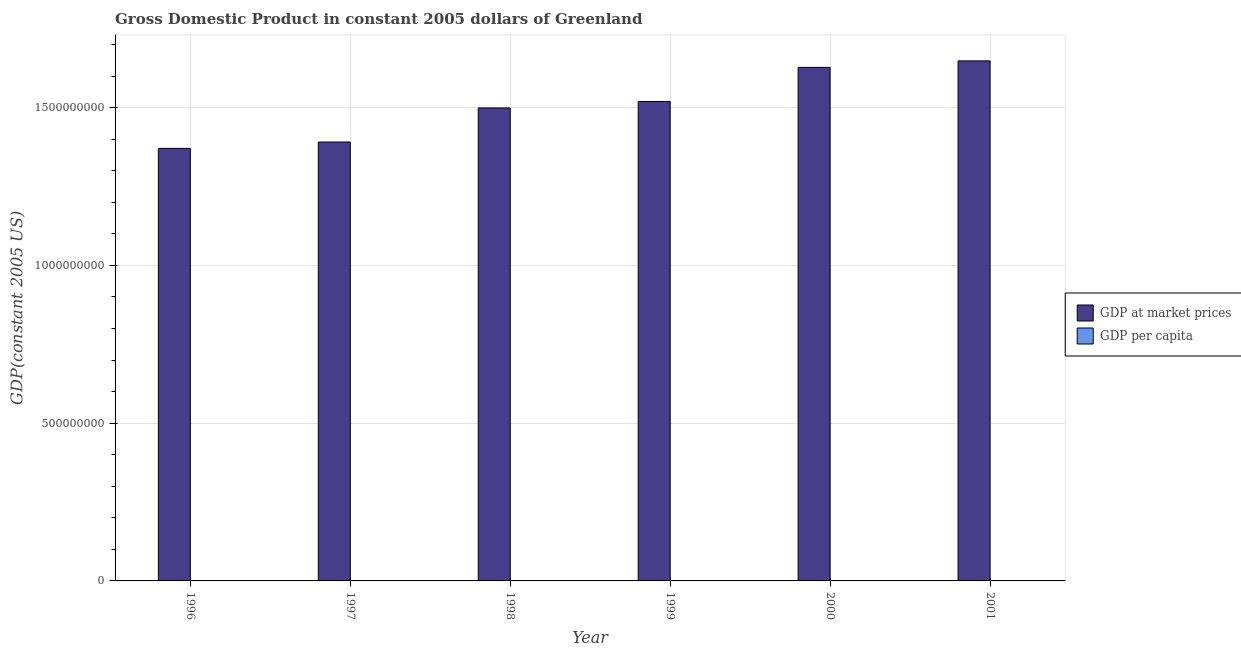How many different coloured bars are there?
Offer a terse response. 2. How many groups of bars are there?
Your answer should be compact. 6. Are the number of bars on each tick of the X-axis equal?
Keep it short and to the point. Yes. How many bars are there on the 1st tick from the left?
Your answer should be compact. 2. What is the label of the 6th group of bars from the left?
Give a very brief answer. 2001. What is the gdp per capita in 2000?
Your response must be concise. 2.90e+04. Across all years, what is the maximum gdp at market prices?
Offer a terse response. 1.65e+09. Across all years, what is the minimum gdp at market prices?
Keep it short and to the point. 1.37e+09. In which year was the gdp per capita minimum?
Provide a succinct answer. 1996. What is the total gdp at market prices in the graph?
Offer a terse response. 9.06e+09. What is the difference between the gdp at market prices in 1996 and that in 1998?
Make the answer very short. -1.28e+08. What is the difference between the gdp per capita in 1996 and the gdp at market prices in 1999?
Ensure brevity in your answer.  -2563.56. What is the average gdp per capita per year?
Provide a short and direct response. 2.69e+04. In how many years, is the gdp per capita greater than 1000000000 US$?
Make the answer very short. 0. What is the ratio of the gdp per capita in 1998 to that in 2000?
Your answer should be compact. 0.92. Is the gdp per capita in 1998 less than that in 2001?
Provide a succinct answer. Yes. Is the difference between the gdp per capita in 1998 and 2001 greater than the difference between the gdp at market prices in 1998 and 2001?
Your response must be concise. No. What is the difference between the highest and the second highest gdp per capita?
Make the answer very short. 289.47. What is the difference between the highest and the lowest gdp at market prices?
Your answer should be very brief. 2.77e+08. In how many years, is the gdp at market prices greater than the average gdp at market prices taken over all years?
Your response must be concise. 3. Is the sum of the gdp per capita in 1999 and 2001 greater than the maximum gdp at market prices across all years?
Offer a very short reply. Yes. What does the 1st bar from the left in 2000 represents?
Provide a succinct answer. GDP at market prices. What does the 2nd bar from the right in 1998 represents?
Keep it short and to the point. GDP at market prices. How many bars are there?
Offer a terse response. 12. Are all the bars in the graph horizontal?
Provide a succinct answer. No. Are the values on the major ticks of Y-axis written in scientific E-notation?
Your answer should be very brief. No. Does the graph contain grids?
Make the answer very short. Yes. What is the title of the graph?
Give a very brief answer. Gross Domestic Product in constant 2005 dollars of Greenland. What is the label or title of the Y-axis?
Your answer should be very brief. GDP(constant 2005 US). What is the GDP(constant 2005 US) in GDP at market prices in 1996?
Your answer should be compact. 1.37e+09. What is the GDP(constant 2005 US) in GDP per capita in 1996?
Make the answer very short. 2.45e+04. What is the GDP(constant 2005 US) in GDP at market prices in 1997?
Offer a terse response. 1.39e+09. What is the GDP(constant 2005 US) in GDP per capita in 1997?
Ensure brevity in your answer.  2.48e+04. What is the GDP(constant 2005 US) in GDP at market prices in 1998?
Offer a terse response. 1.50e+09. What is the GDP(constant 2005 US) in GDP per capita in 1998?
Your response must be concise. 2.67e+04. What is the GDP(constant 2005 US) in GDP at market prices in 1999?
Your answer should be very brief. 1.52e+09. What is the GDP(constant 2005 US) of GDP per capita in 1999?
Your answer should be compact. 2.71e+04. What is the GDP(constant 2005 US) in GDP at market prices in 2000?
Provide a succinct answer. 1.63e+09. What is the GDP(constant 2005 US) of GDP per capita in 2000?
Offer a very short reply. 2.90e+04. What is the GDP(constant 2005 US) of GDP at market prices in 2001?
Your response must be concise. 1.65e+09. What is the GDP(constant 2005 US) in GDP per capita in 2001?
Offer a very short reply. 2.93e+04. Across all years, what is the maximum GDP(constant 2005 US) in GDP at market prices?
Ensure brevity in your answer.  1.65e+09. Across all years, what is the maximum GDP(constant 2005 US) in GDP per capita?
Your answer should be very brief. 2.93e+04. Across all years, what is the minimum GDP(constant 2005 US) of GDP at market prices?
Your answer should be compact. 1.37e+09. Across all years, what is the minimum GDP(constant 2005 US) in GDP per capita?
Make the answer very short. 2.45e+04. What is the total GDP(constant 2005 US) in GDP at market prices in the graph?
Provide a succinct answer. 9.06e+09. What is the total GDP(constant 2005 US) of GDP per capita in the graph?
Offer a very short reply. 1.61e+05. What is the difference between the GDP(constant 2005 US) in GDP at market prices in 1996 and that in 1997?
Make the answer very short. -2.01e+07. What is the difference between the GDP(constant 2005 US) in GDP per capita in 1996 and that in 1997?
Offer a very short reply. -315.83. What is the difference between the GDP(constant 2005 US) of GDP at market prices in 1996 and that in 1998?
Offer a terse response. -1.28e+08. What is the difference between the GDP(constant 2005 US) of GDP per capita in 1996 and that in 1998?
Provide a succinct answer. -2195.36. What is the difference between the GDP(constant 2005 US) in GDP at market prices in 1996 and that in 1999?
Your answer should be compact. -1.49e+08. What is the difference between the GDP(constant 2005 US) in GDP per capita in 1996 and that in 1999?
Offer a terse response. -2563.56. What is the difference between the GDP(constant 2005 US) in GDP at market prices in 1996 and that in 2000?
Give a very brief answer. -2.57e+08. What is the difference between the GDP(constant 2005 US) of GDP per capita in 1996 and that in 2000?
Keep it short and to the point. -4435.74. What is the difference between the GDP(constant 2005 US) in GDP at market prices in 1996 and that in 2001?
Your response must be concise. -2.77e+08. What is the difference between the GDP(constant 2005 US) in GDP per capita in 1996 and that in 2001?
Your response must be concise. -4725.21. What is the difference between the GDP(constant 2005 US) of GDP at market prices in 1997 and that in 1998?
Provide a short and direct response. -1.08e+08. What is the difference between the GDP(constant 2005 US) in GDP per capita in 1997 and that in 1998?
Make the answer very short. -1879.53. What is the difference between the GDP(constant 2005 US) of GDP at market prices in 1997 and that in 1999?
Keep it short and to the point. -1.29e+08. What is the difference between the GDP(constant 2005 US) in GDP per capita in 1997 and that in 1999?
Provide a succinct answer. -2247.72. What is the difference between the GDP(constant 2005 US) of GDP at market prices in 1997 and that in 2000?
Keep it short and to the point. -2.37e+08. What is the difference between the GDP(constant 2005 US) in GDP per capita in 1997 and that in 2000?
Your answer should be compact. -4119.91. What is the difference between the GDP(constant 2005 US) of GDP at market prices in 1997 and that in 2001?
Offer a terse response. -2.57e+08. What is the difference between the GDP(constant 2005 US) in GDP per capita in 1997 and that in 2001?
Provide a succinct answer. -4409.38. What is the difference between the GDP(constant 2005 US) in GDP at market prices in 1998 and that in 1999?
Make the answer very short. -2.07e+07. What is the difference between the GDP(constant 2005 US) in GDP per capita in 1998 and that in 1999?
Ensure brevity in your answer.  -368.19. What is the difference between the GDP(constant 2005 US) of GDP at market prices in 1998 and that in 2000?
Your response must be concise. -1.29e+08. What is the difference between the GDP(constant 2005 US) in GDP per capita in 1998 and that in 2000?
Offer a very short reply. -2240.38. What is the difference between the GDP(constant 2005 US) in GDP at market prices in 1998 and that in 2001?
Give a very brief answer. -1.49e+08. What is the difference between the GDP(constant 2005 US) in GDP per capita in 1998 and that in 2001?
Provide a short and direct response. -2529.85. What is the difference between the GDP(constant 2005 US) of GDP at market prices in 1999 and that in 2000?
Offer a very short reply. -1.08e+08. What is the difference between the GDP(constant 2005 US) in GDP per capita in 1999 and that in 2000?
Make the answer very short. -1872.19. What is the difference between the GDP(constant 2005 US) of GDP at market prices in 1999 and that in 2001?
Offer a very short reply. -1.29e+08. What is the difference between the GDP(constant 2005 US) of GDP per capita in 1999 and that in 2001?
Your answer should be very brief. -2161.65. What is the difference between the GDP(constant 2005 US) in GDP at market prices in 2000 and that in 2001?
Offer a terse response. -2.07e+07. What is the difference between the GDP(constant 2005 US) of GDP per capita in 2000 and that in 2001?
Keep it short and to the point. -289.47. What is the difference between the GDP(constant 2005 US) of GDP at market prices in 1996 and the GDP(constant 2005 US) of GDP per capita in 1997?
Provide a succinct answer. 1.37e+09. What is the difference between the GDP(constant 2005 US) of GDP at market prices in 1996 and the GDP(constant 2005 US) of GDP per capita in 1998?
Provide a succinct answer. 1.37e+09. What is the difference between the GDP(constant 2005 US) of GDP at market prices in 1996 and the GDP(constant 2005 US) of GDP per capita in 1999?
Your answer should be very brief. 1.37e+09. What is the difference between the GDP(constant 2005 US) of GDP at market prices in 1996 and the GDP(constant 2005 US) of GDP per capita in 2000?
Offer a very short reply. 1.37e+09. What is the difference between the GDP(constant 2005 US) in GDP at market prices in 1996 and the GDP(constant 2005 US) in GDP per capita in 2001?
Make the answer very short. 1.37e+09. What is the difference between the GDP(constant 2005 US) in GDP at market prices in 1997 and the GDP(constant 2005 US) in GDP per capita in 1998?
Provide a short and direct response. 1.39e+09. What is the difference between the GDP(constant 2005 US) of GDP at market prices in 1997 and the GDP(constant 2005 US) of GDP per capita in 1999?
Your answer should be very brief. 1.39e+09. What is the difference between the GDP(constant 2005 US) of GDP at market prices in 1997 and the GDP(constant 2005 US) of GDP per capita in 2000?
Ensure brevity in your answer.  1.39e+09. What is the difference between the GDP(constant 2005 US) in GDP at market prices in 1997 and the GDP(constant 2005 US) in GDP per capita in 2001?
Your response must be concise. 1.39e+09. What is the difference between the GDP(constant 2005 US) in GDP at market prices in 1998 and the GDP(constant 2005 US) in GDP per capita in 1999?
Keep it short and to the point. 1.50e+09. What is the difference between the GDP(constant 2005 US) of GDP at market prices in 1998 and the GDP(constant 2005 US) of GDP per capita in 2000?
Provide a succinct answer. 1.50e+09. What is the difference between the GDP(constant 2005 US) of GDP at market prices in 1998 and the GDP(constant 2005 US) of GDP per capita in 2001?
Keep it short and to the point. 1.50e+09. What is the difference between the GDP(constant 2005 US) in GDP at market prices in 1999 and the GDP(constant 2005 US) in GDP per capita in 2000?
Make the answer very short. 1.52e+09. What is the difference between the GDP(constant 2005 US) of GDP at market prices in 1999 and the GDP(constant 2005 US) of GDP per capita in 2001?
Provide a succinct answer. 1.52e+09. What is the difference between the GDP(constant 2005 US) in GDP at market prices in 2000 and the GDP(constant 2005 US) in GDP per capita in 2001?
Keep it short and to the point. 1.63e+09. What is the average GDP(constant 2005 US) in GDP at market prices per year?
Provide a succinct answer. 1.51e+09. What is the average GDP(constant 2005 US) in GDP per capita per year?
Ensure brevity in your answer.  2.69e+04. In the year 1996, what is the difference between the GDP(constant 2005 US) in GDP at market prices and GDP(constant 2005 US) in GDP per capita?
Your answer should be compact. 1.37e+09. In the year 1997, what is the difference between the GDP(constant 2005 US) in GDP at market prices and GDP(constant 2005 US) in GDP per capita?
Keep it short and to the point. 1.39e+09. In the year 1998, what is the difference between the GDP(constant 2005 US) of GDP at market prices and GDP(constant 2005 US) of GDP per capita?
Ensure brevity in your answer.  1.50e+09. In the year 1999, what is the difference between the GDP(constant 2005 US) in GDP at market prices and GDP(constant 2005 US) in GDP per capita?
Offer a terse response. 1.52e+09. In the year 2000, what is the difference between the GDP(constant 2005 US) in GDP at market prices and GDP(constant 2005 US) in GDP per capita?
Provide a succinct answer. 1.63e+09. In the year 2001, what is the difference between the GDP(constant 2005 US) in GDP at market prices and GDP(constant 2005 US) in GDP per capita?
Keep it short and to the point. 1.65e+09. What is the ratio of the GDP(constant 2005 US) in GDP at market prices in 1996 to that in 1997?
Offer a terse response. 0.99. What is the ratio of the GDP(constant 2005 US) in GDP per capita in 1996 to that in 1997?
Your response must be concise. 0.99. What is the ratio of the GDP(constant 2005 US) in GDP at market prices in 1996 to that in 1998?
Make the answer very short. 0.91. What is the ratio of the GDP(constant 2005 US) in GDP per capita in 1996 to that in 1998?
Make the answer very short. 0.92. What is the ratio of the GDP(constant 2005 US) of GDP at market prices in 1996 to that in 1999?
Your response must be concise. 0.9. What is the ratio of the GDP(constant 2005 US) in GDP per capita in 1996 to that in 1999?
Ensure brevity in your answer.  0.91. What is the ratio of the GDP(constant 2005 US) in GDP at market prices in 1996 to that in 2000?
Keep it short and to the point. 0.84. What is the ratio of the GDP(constant 2005 US) in GDP per capita in 1996 to that in 2000?
Keep it short and to the point. 0.85. What is the ratio of the GDP(constant 2005 US) of GDP at market prices in 1996 to that in 2001?
Keep it short and to the point. 0.83. What is the ratio of the GDP(constant 2005 US) in GDP per capita in 1996 to that in 2001?
Your answer should be compact. 0.84. What is the ratio of the GDP(constant 2005 US) in GDP at market prices in 1997 to that in 1998?
Offer a very short reply. 0.93. What is the ratio of the GDP(constant 2005 US) of GDP per capita in 1997 to that in 1998?
Ensure brevity in your answer.  0.93. What is the ratio of the GDP(constant 2005 US) in GDP at market prices in 1997 to that in 1999?
Offer a terse response. 0.92. What is the ratio of the GDP(constant 2005 US) of GDP per capita in 1997 to that in 1999?
Your answer should be very brief. 0.92. What is the ratio of the GDP(constant 2005 US) of GDP at market prices in 1997 to that in 2000?
Provide a succinct answer. 0.85. What is the ratio of the GDP(constant 2005 US) in GDP per capita in 1997 to that in 2000?
Make the answer very short. 0.86. What is the ratio of the GDP(constant 2005 US) in GDP at market prices in 1997 to that in 2001?
Your response must be concise. 0.84. What is the ratio of the GDP(constant 2005 US) in GDP per capita in 1997 to that in 2001?
Give a very brief answer. 0.85. What is the ratio of the GDP(constant 2005 US) in GDP at market prices in 1998 to that in 1999?
Give a very brief answer. 0.99. What is the ratio of the GDP(constant 2005 US) of GDP per capita in 1998 to that in 1999?
Give a very brief answer. 0.99. What is the ratio of the GDP(constant 2005 US) of GDP at market prices in 1998 to that in 2000?
Your response must be concise. 0.92. What is the ratio of the GDP(constant 2005 US) of GDP per capita in 1998 to that in 2000?
Make the answer very short. 0.92. What is the ratio of the GDP(constant 2005 US) of GDP at market prices in 1998 to that in 2001?
Provide a succinct answer. 0.91. What is the ratio of the GDP(constant 2005 US) in GDP per capita in 1998 to that in 2001?
Offer a terse response. 0.91. What is the ratio of the GDP(constant 2005 US) in GDP at market prices in 1999 to that in 2000?
Ensure brevity in your answer.  0.93. What is the ratio of the GDP(constant 2005 US) in GDP per capita in 1999 to that in 2000?
Provide a short and direct response. 0.94. What is the ratio of the GDP(constant 2005 US) in GDP at market prices in 1999 to that in 2001?
Keep it short and to the point. 0.92. What is the ratio of the GDP(constant 2005 US) in GDP per capita in 1999 to that in 2001?
Make the answer very short. 0.93. What is the ratio of the GDP(constant 2005 US) in GDP at market prices in 2000 to that in 2001?
Keep it short and to the point. 0.99. What is the difference between the highest and the second highest GDP(constant 2005 US) in GDP at market prices?
Offer a very short reply. 2.07e+07. What is the difference between the highest and the second highest GDP(constant 2005 US) in GDP per capita?
Your answer should be compact. 289.47. What is the difference between the highest and the lowest GDP(constant 2005 US) of GDP at market prices?
Your response must be concise. 2.77e+08. What is the difference between the highest and the lowest GDP(constant 2005 US) of GDP per capita?
Your answer should be compact. 4725.21. 